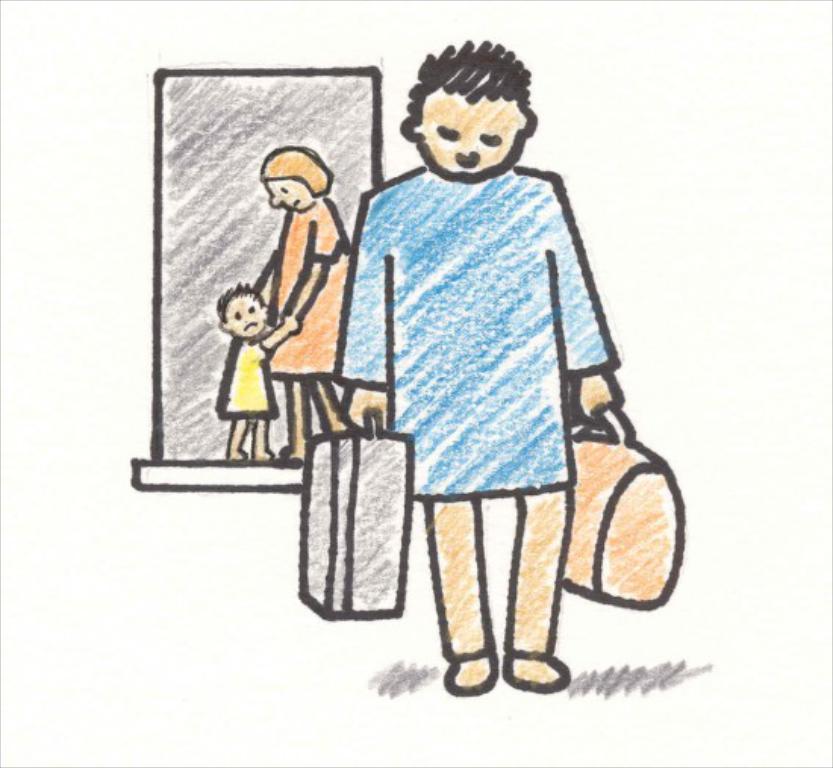Can you describe this image briefly? This image is a painting in this painting we can see a man standing and holding bags in his hand. In the background there is a lady and a kid. We can see a door. 